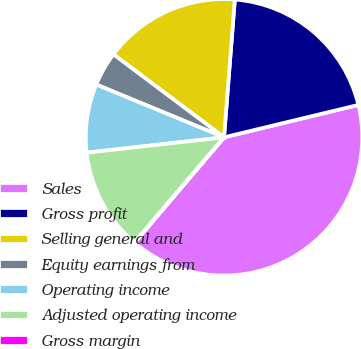Convert chart to OTSL. <chart><loc_0><loc_0><loc_500><loc_500><pie_chart><fcel>Sales<fcel>Gross profit<fcel>Selling general and<fcel>Equity earnings from<fcel>Operating income<fcel>Adjusted operating income<fcel>Gross margin<nl><fcel>39.97%<fcel>19.99%<fcel>16.0%<fcel>4.01%<fcel>8.01%<fcel>12.0%<fcel>0.02%<nl></chart> 